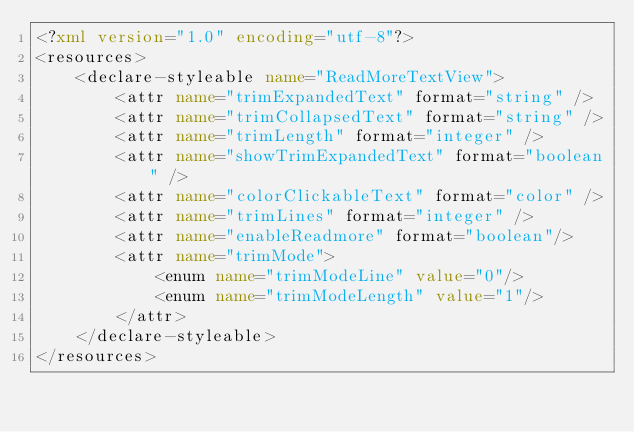<code> <loc_0><loc_0><loc_500><loc_500><_XML_><?xml version="1.0" encoding="utf-8"?>
<resources>
    <declare-styleable name="ReadMoreTextView">
        <attr name="trimExpandedText" format="string" />
        <attr name="trimCollapsedText" format="string" />
        <attr name="trimLength" format="integer" />
        <attr name="showTrimExpandedText" format="boolean" />
        <attr name="colorClickableText" format="color" />
        <attr name="trimLines" format="integer" />
        <attr name="enableReadmore" format="boolean"/>
        <attr name="trimMode">
            <enum name="trimModeLine" value="0"/>
            <enum name="trimModeLength" value="1"/>
        </attr>
    </declare-styleable>
</resources></code> 